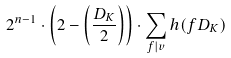<formula> <loc_0><loc_0><loc_500><loc_500>2 ^ { n - 1 } \cdot \left ( 2 - \left ( \frac { D _ { K } } { 2 } \right ) \right ) \cdot \sum _ { f | v } h ( f D _ { K } )</formula> 